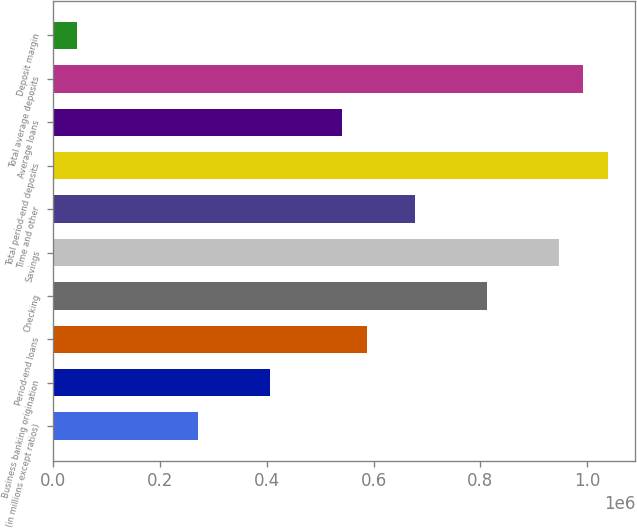Convert chart to OTSL. <chart><loc_0><loc_0><loc_500><loc_500><bar_chart><fcel>(in millions except ratios)<fcel>Business banking origination<fcel>Period-end loans<fcel>Checking<fcel>Savings<fcel>Time and other<fcel>Total period-end deposits<fcel>Average loans<fcel>Total average deposits<fcel>Deposit margin<nl><fcel>270857<fcel>406284<fcel>586855<fcel>812567<fcel>947995<fcel>677140<fcel>1.03828e+06<fcel>541712<fcel>993137<fcel>45144.3<nl></chart> 